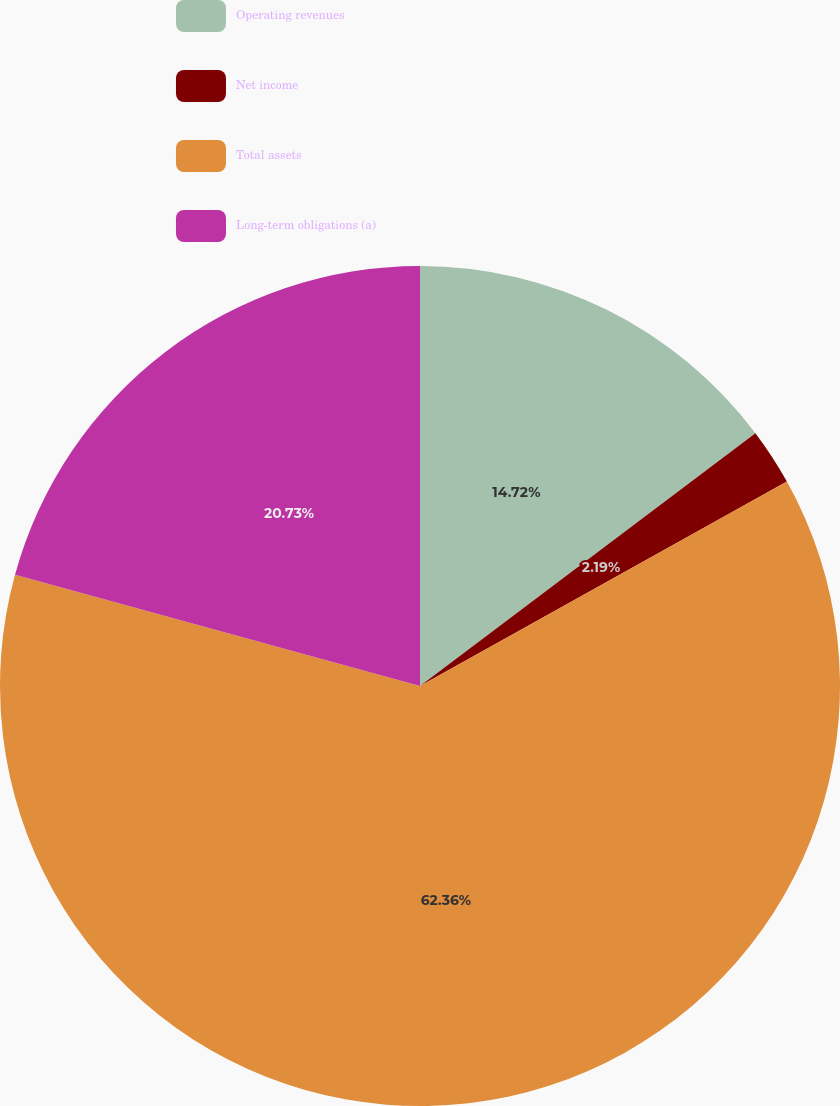Convert chart to OTSL. <chart><loc_0><loc_0><loc_500><loc_500><pie_chart><fcel>Operating revenues<fcel>Net income<fcel>Total assets<fcel>Long-term obligations (a)<nl><fcel>14.72%<fcel>2.19%<fcel>62.36%<fcel>20.73%<nl></chart> 